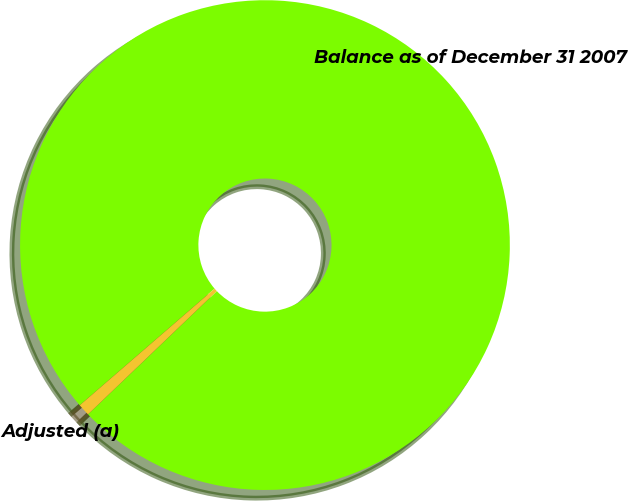Convert chart. <chart><loc_0><loc_0><loc_500><loc_500><pie_chart><fcel>Balance as of December 31 2007<fcel>Adjusted (a)<nl><fcel>99.2%<fcel>0.8%<nl></chart> 